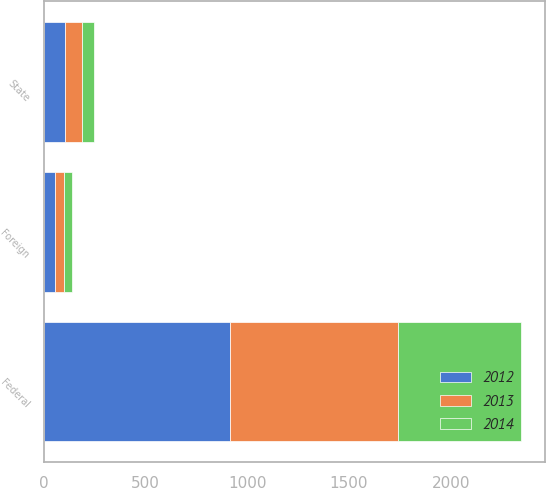<chart> <loc_0><loc_0><loc_500><loc_500><stacked_bar_chart><ecel><fcel>Federal<fcel>State<fcel>Foreign<nl><fcel>2012<fcel>916<fcel>102<fcel>52<nl><fcel>2013<fcel>827<fcel>86<fcel>44<nl><fcel>2014<fcel>604<fcel>58<fcel>43<nl></chart> 